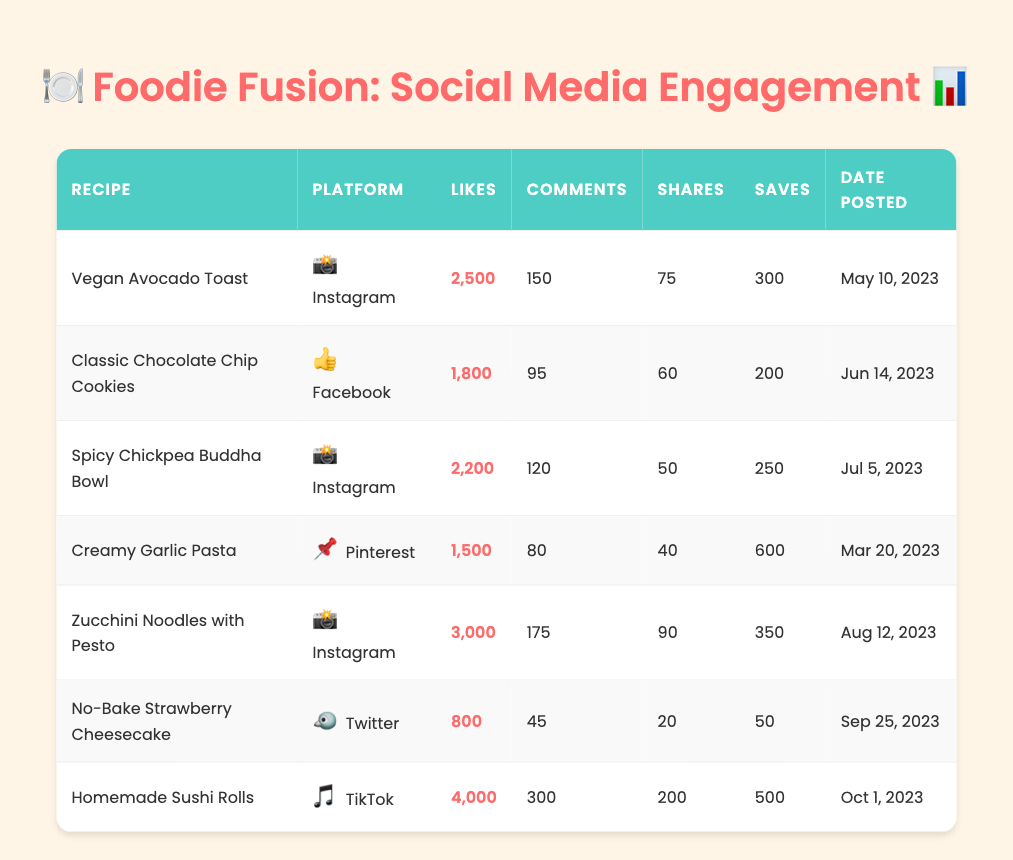What is the recipe with the highest number of likes? By looking at the table, the recipe with the highest likes is "Homemade Sushi Rolls" with 4,000 likes.
Answer: Homemade Sushi Rolls How many shares did the "Vegan Avocado Toast" receive? The table lists "Vegan Avocado Toast" with a total of 75 shares.
Answer: 75 shares Which platform had the least engagement in terms of likes for its recipe post? Upon examining the "likes" column, "No-Bake Strawberry Cheesecake" on Twitter had the least likes with a total of 800.
Answer: Twitter What is the total number of comments across all the Instagram posts? The comments for Instagram posts are 150 (Vegan Avocado Toast), 120 (Spicy Chickpea Buddha Bowl), and 175 (Zucchini Noodles with Pesto). Summing these gives: 150 + 120 + 175 = 445.
Answer: 445 Which recipe had the highest engagement in terms of saves? In the table, "Homemade Sushi Rolls" has the highest saves with a total of 500.
Answer: Homemade Sushi Rolls Is there a recipe that received more saves than likes? The "Creamy Garlic Pasta" received 600 saves and only 1,500 likes, so the answer is yes.
Answer: Yes What is the average number of likes for all the recipes posted? The total likes are 2500 + 1800 + 2200 + 1500 + 3000 + 800 + 4000 = 14,800. With 7 recipes, the average likes are 14,800 / 7 = approximately 2,114.
Answer: Approximately 2,114 Which recipe had more shares: "Zucchini Noodles with Pesto" or "Spicy Chickpea Buddha Bowl"? "Zucchini Noodles with Pesto" received 90 shares, while "Spicy Chickpea Buddha Bowl" received 50 shares. Since 90 > 50, "Zucchini Noodles with Pesto" had more shares.
Answer: Zucchini Noodles with Pesto On which date was the most engaged recipe posted? The recipe "Homemade Sushi Rolls" received the highest engagement and was posted on October 1, 2023.
Answer: October 1, 2023 What is the total number of engagements (likes, comments, shares, and saves) for the "Classic Chocolate Chip Cookies"? For "Classic Chocolate Chip Cookies," the total engagements are calculated as follows: 1800 (likes) + 95 (comments) + 60 (shares) + 200 (saves) = 2,155.
Answer: 2,155 